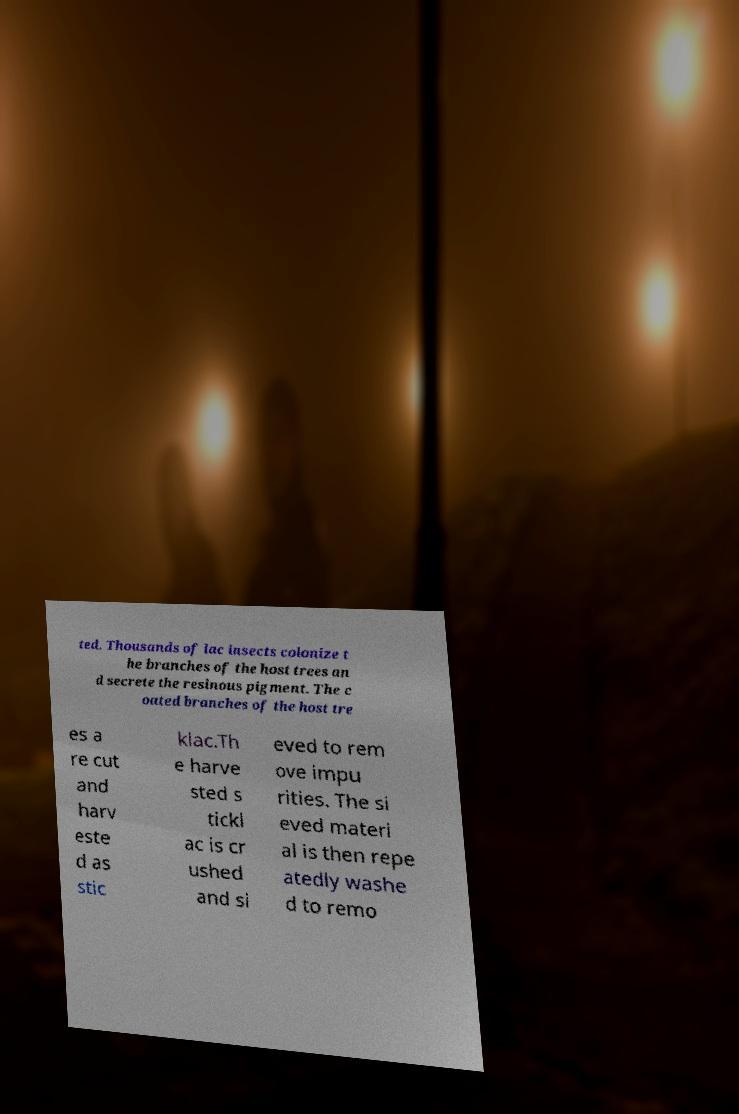Can you accurately transcribe the text from the provided image for me? ted. Thousands of lac insects colonize t he branches of the host trees an d secrete the resinous pigment. The c oated branches of the host tre es a re cut and harv este d as stic klac.Th e harve sted s tickl ac is cr ushed and si eved to rem ove impu rities. The si eved materi al is then repe atedly washe d to remo 